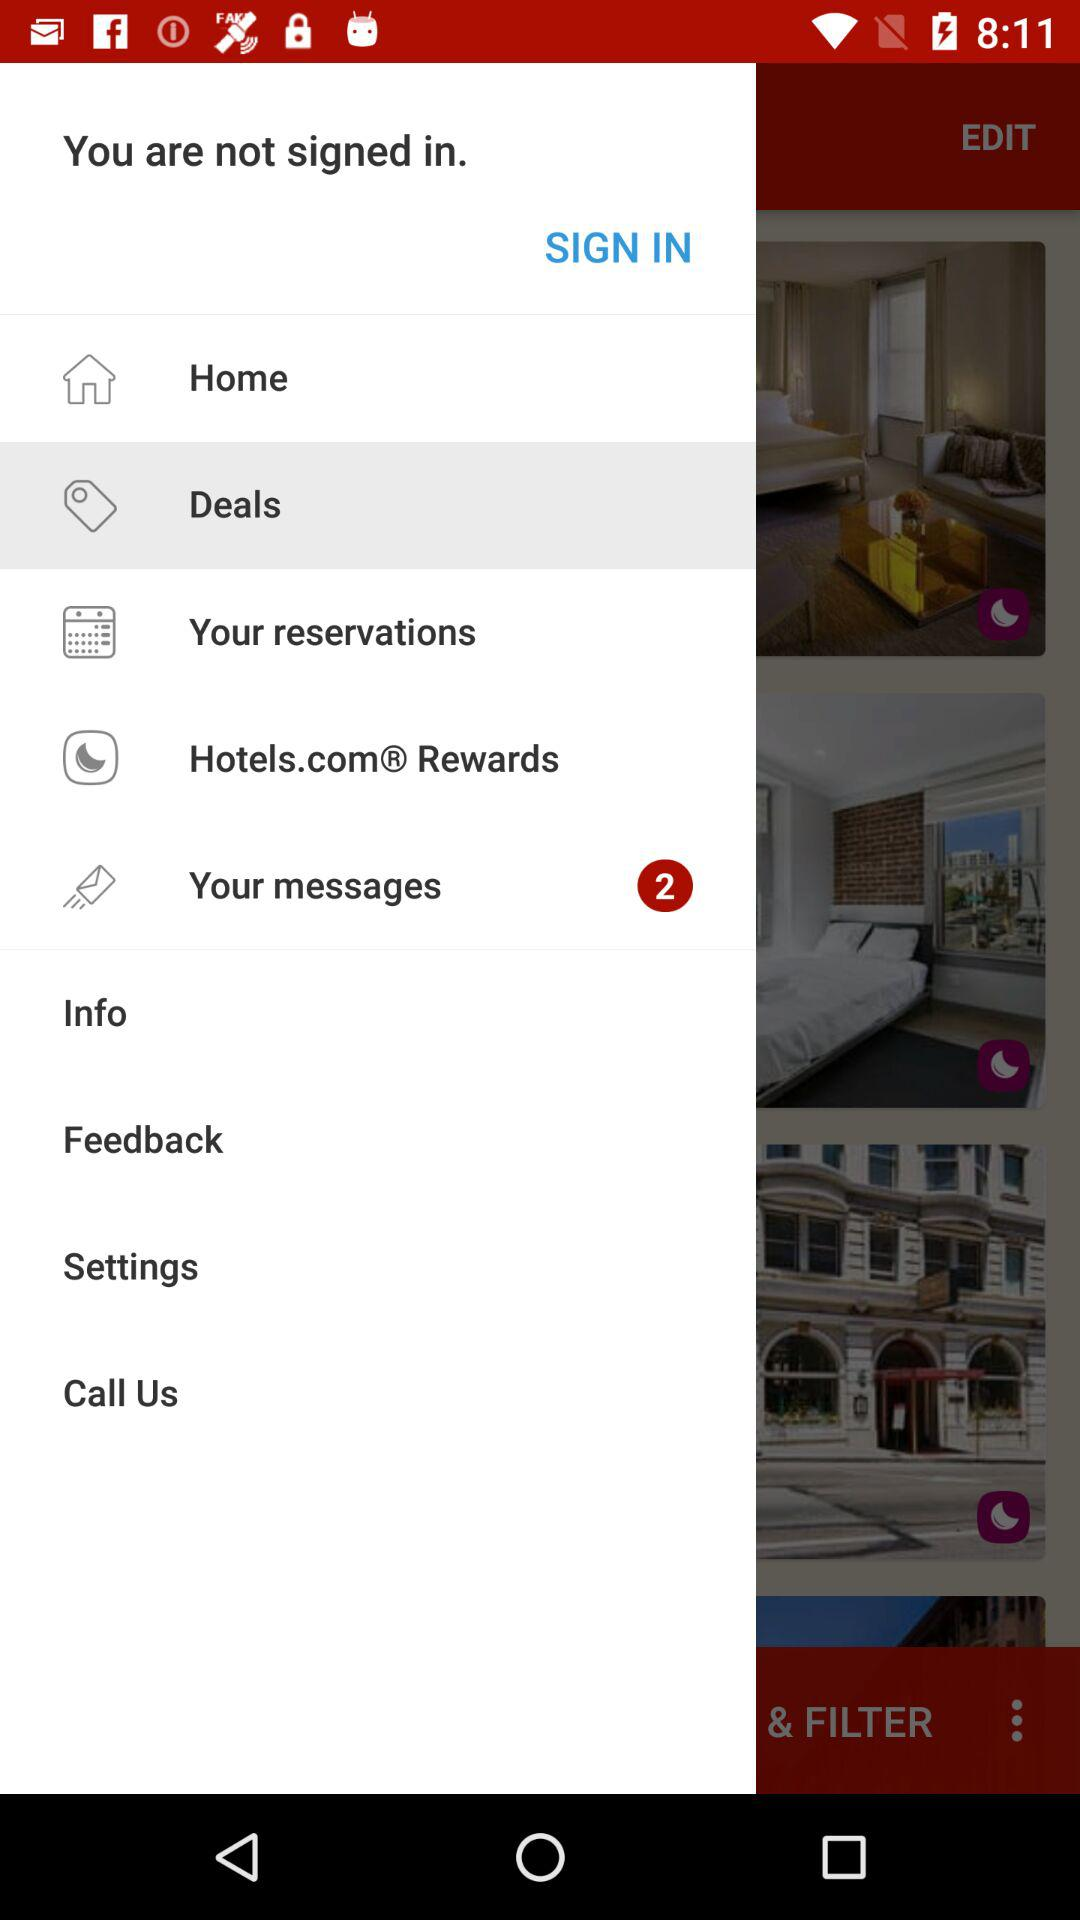How many messages are received? There are 2 messages received. 